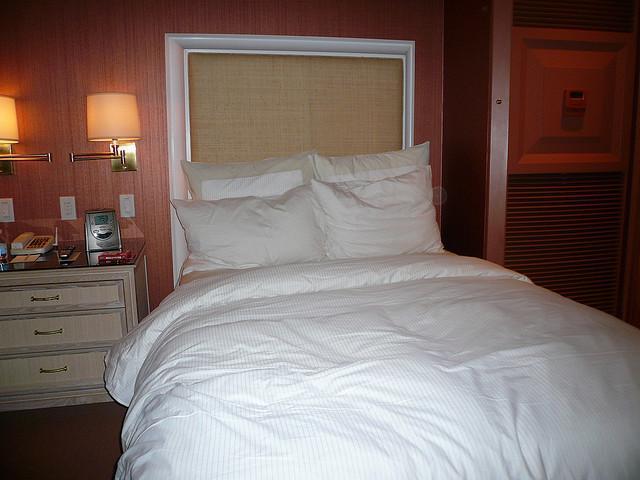How many lamps are in the picture?
Give a very brief answer. 2. How many non-white pillows are on the bed?
Give a very brief answer. 0. How many pillows are there?
Give a very brief answer. 4. How many pillows are on the bed?
Give a very brief answer. 4. 